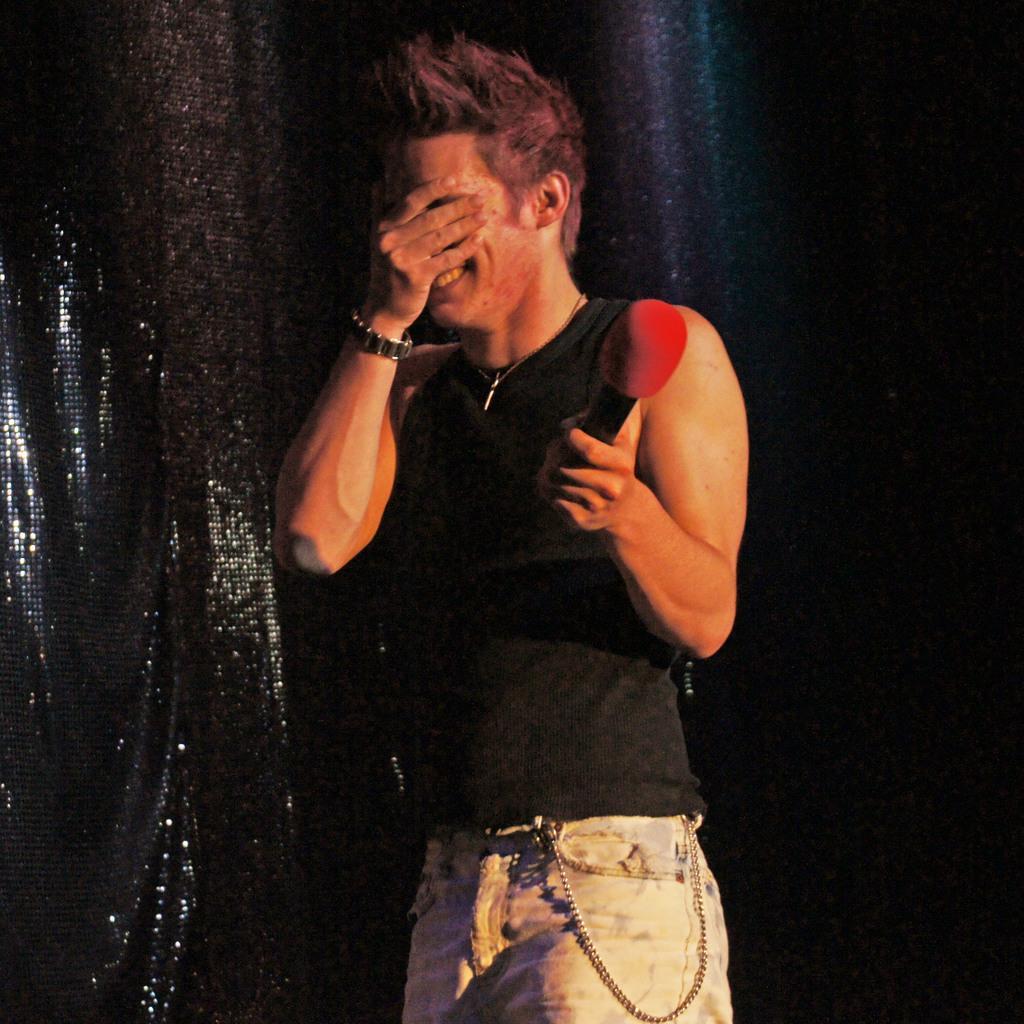Please provide a concise description of this image. In this image I can see a man is standing, I can also see he is holding a mic and I can see smile on his face. He has covered his face from his hand. 